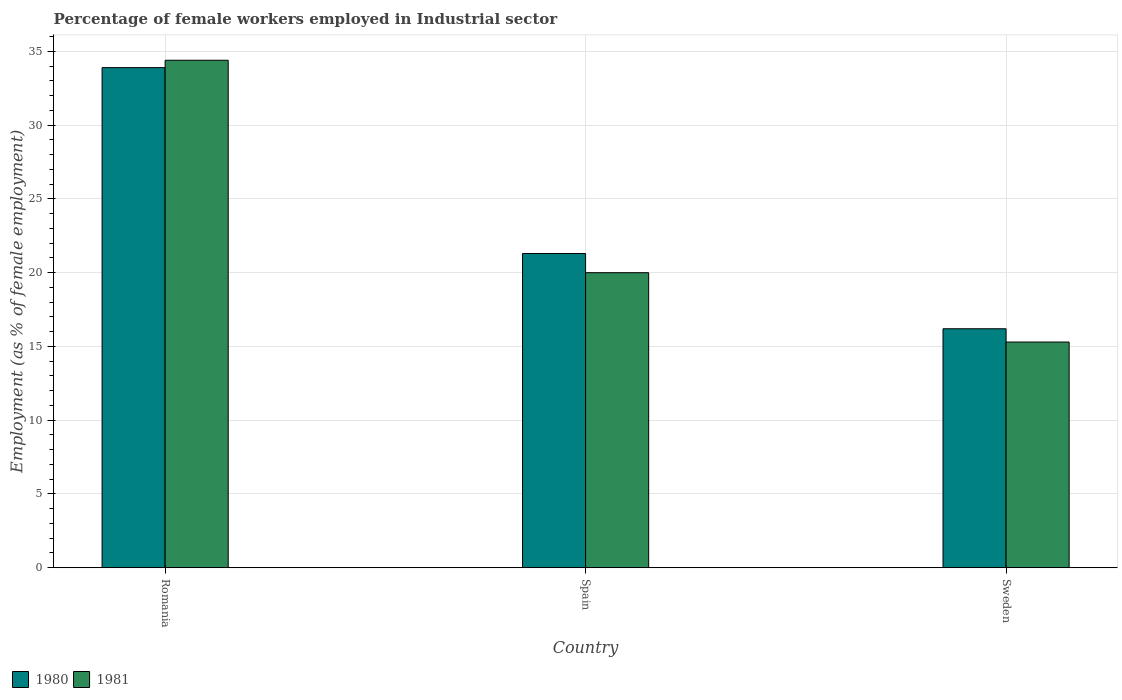Are the number of bars on each tick of the X-axis equal?
Make the answer very short. Yes. How many bars are there on the 1st tick from the right?
Your answer should be very brief. 2. In how many cases, is the number of bars for a given country not equal to the number of legend labels?
Provide a short and direct response. 0. Across all countries, what is the maximum percentage of females employed in Industrial sector in 1980?
Keep it short and to the point. 33.9. Across all countries, what is the minimum percentage of females employed in Industrial sector in 1981?
Make the answer very short. 15.3. In which country was the percentage of females employed in Industrial sector in 1980 maximum?
Your answer should be compact. Romania. What is the total percentage of females employed in Industrial sector in 1980 in the graph?
Ensure brevity in your answer.  71.4. What is the difference between the percentage of females employed in Industrial sector in 1980 in Romania and that in Sweden?
Your response must be concise. 17.7. What is the difference between the percentage of females employed in Industrial sector in 1981 in Sweden and the percentage of females employed in Industrial sector in 1980 in Spain?
Your answer should be very brief. -6. What is the average percentage of females employed in Industrial sector in 1980 per country?
Ensure brevity in your answer.  23.8. What is the difference between the percentage of females employed in Industrial sector of/in 1981 and percentage of females employed in Industrial sector of/in 1980 in Sweden?
Ensure brevity in your answer.  -0.9. In how many countries, is the percentage of females employed in Industrial sector in 1980 greater than 10 %?
Ensure brevity in your answer.  3. What is the ratio of the percentage of females employed in Industrial sector in 1981 in Romania to that in Spain?
Your response must be concise. 1.72. Is the difference between the percentage of females employed in Industrial sector in 1981 in Romania and Sweden greater than the difference between the percentage of females employed in Industrial sector in 1980 in Romania and Sweden?
Give a very brief answer. Yes. What is the difference between the highest and the second highest percentage of females employed in Industrial sector in 1981?
Your response must be concise. 14.4. What is the difference between the highest and the lowest percentage of females employed in Industrial sector in 1981?
Give a very brief answer. 19.1. In how many countries, is the percentage of females employed in Industrial sector in 1981 greater than the average percentage of females employed in Industrial sector in 1981 taken over all countries?
Your answer should be compact. 1. What does the 1st bar from the right in Sweden represents?
Offer a very short reply. 1981. How many bars are there?
Offer a terse response. 6. Are the values on the major ticks of Y-axis written in scientific E-notation?
Offer a very short reply. No. Does the graph contain grids?
Your response must be concise. Yes. Where does the legend appear in the graph?
Your answer should be compact. Bottom left. What is the title of the graph?
Keep it short and to the point. Percentage of female workers employed in Industrial sector. Does "1969" appear as one of the legend labels in the graph?
Offer a very short reply. No. What is the label or title of the Y-axis?
Keep it short and to the point. Employment (as % of female employment). What is the Employment (as % of female employment) of 1980 in Romania?
Make the answer very short. 33.9. What is the Employment (as % of female employment) in 1981 in Romania?
Provide a succinct answer. 34.4. What is the Employment (as % of female employment) of 1980 in Spain?
Provide a succinct answer. 21.3. What is the Employment (as % of female employment) in 1980 in Sweden?
Your answer should be compact. 16.2. What is the Employment (as % of female employment) in 1981 in Sweden?
Your answer should be compact. 15.3. Across all countries, what is the maximum Employment (as % of female employment) of 1980?
Ensure brevity in your answer.  33.9. Across all countries, what is the maximum Employment (as % of female employment) of 1981?
Offer a very short reply. 34.4. Across all countries, what is the minimum Employment (as % of female employment) in 1980?
Make the answer very short. 16.2. Across all countries, what is the minimum Employment (as % of female employment) of 1981?
Offer a very short reply. 15.3. What is the total Employment (as % of female employment) in 1980 in the graph?
Give a very brief answer. 71.4. What is the total Employment (as % of female employment) of 1981 in the graph?
Provide a short and direct response. 69.7. What is the difference between the Employment (as % of female employment) in 1980 in Romania and that in Spain?
Offer a very short reply. 12.6. What is the difference between the Employment (as % of female employment) in 1980 in Spain and that in Sweden?
Keep it short and to the point. 5.1. What is the difference between the Employment (as % of female employment) in 1980 in Romania and the Employment (as % of female employment) in 1981 in Spain?
Make the answer very short. 13.9. What is the difference between the Employment (as % of female employment) in 1980 in Romania and the Employment (as % of female employment) in 1981 in Sweden?
Your response must be concise. 18.6. What is the difference between the Employment (as % of female employment) of 1980 in Spain and the Employment (as % of female employment) of 1981 in Sweden?
Offer a very short reply. 6. What is the average Employment (as % of female employment) in 1980 per country?
Your answer should be very brief. 23.8. What is the average Employment (as % of female employment) in 1981 per country?
Your response must be concise. 23.23. What is the difference between the Employment (as % of female employment) in 1980 and Employment (as % of female employment) in 1981 in Sweden?
Provide a short and direct response. 0.9. What is the ratio of the Employment (as % of female employment) of 1980 in Romania to that in Spain?
Provide a short and direct response. 1.59. What is the ratio of the Employment (as % of female employment) of 1981 in Romania to that in Spain?
Provide a succinct answer. 1.72. What is the ratio of the Employment (as % of female employment) of 1980 in Romania to that in Sweden?
Give a very brief answer. 2.09. What is the ratio of the Employment (as % of female employment) of 1981 in Romania to that in Sweden?
Keep it short and to the point. 2.25. What is the ratio of the Employment (as % of female employment) in 1980 in Spain to that in Sweden?
Give a very brief answer. 1.31. What is the ratio of the Employment (as % of female employment) of 1981 in Spain to that in Sweden?
Offer a terse response. 1.31. What is the difference between the highest and the second highest Employment (as % of female employment) in 1980?
Offer a very short reply. 12.6. What is the difference between the highest and the second highest Employment (as % of female employment) of 1981?
Ensure brevity in your answer.  14.4. What is the difference between the highest and the lowest Employment (as % of female employment) of 1981?
Make the answer very short. 19.1. 